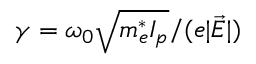<formula> <loc_0><loc_0><loc_500><loc_500>\gamma = \omega _ { 0 } \sqrt { m _ { e } ^ { * } I _ { p } } / ( e | \vec { E } | )</formula> 